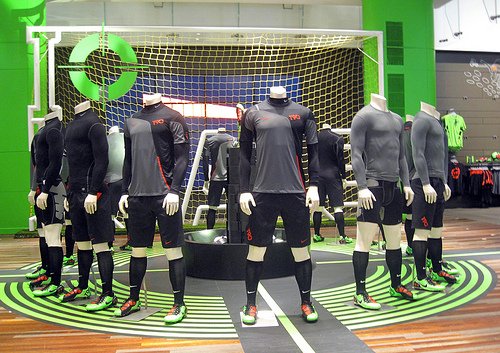<image>
Can you confirm if the shoe is in front of the net? Yes. The shoe is positioned in front of the net, appearing closer to the camera viewpoint. 